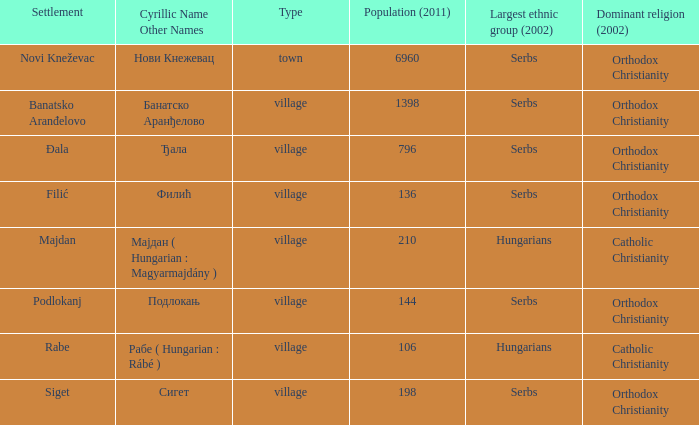Which community has the cyrillic name сигет? Siget. Could you help me parse every detail presented in this table? {'header': ['Settlement', 'Cyrillic Name Other Names', 'Type', 'Population (2011)', 'Largest ethnic group (2002)', 'Dominant religion (2002)'], 'rows': [['Novi Kneževac', 'Нови Кнежевац', 'town', '6960', 'Serbs', 'Orthodox Christianity'], ['Banatsko Aranđelovo', 'Банатско Аранђелово', 'village', '1398', 'Serbs', 'Orthodox Christianity'], ['Đala', 'Ђала', 'village', '796', 'Serbs', 'Orthodox Christianity'], ['Filić', 'Филић', 'village', '136', 'Serbs', 'Orthodox Christianity'], ['Majdan', 'Мајдан ( Hungarian : Magyarmajdány )', 'village', '210', 'Hungarians', 'Catholic Christianity'], ['Podlokanj', 'Подлокањ', 'village', '144', 'Serbs', 'Orthodox Christianity'], ['Rabe', 'Рабе ( Hungarian : Rábé )', 'village', '106', 'Hungarians', 'Catholic Christianity'], ['Siget', 'Сигет', 'village', '198', 'Serbs', 'Orthodox Christianity']]} 